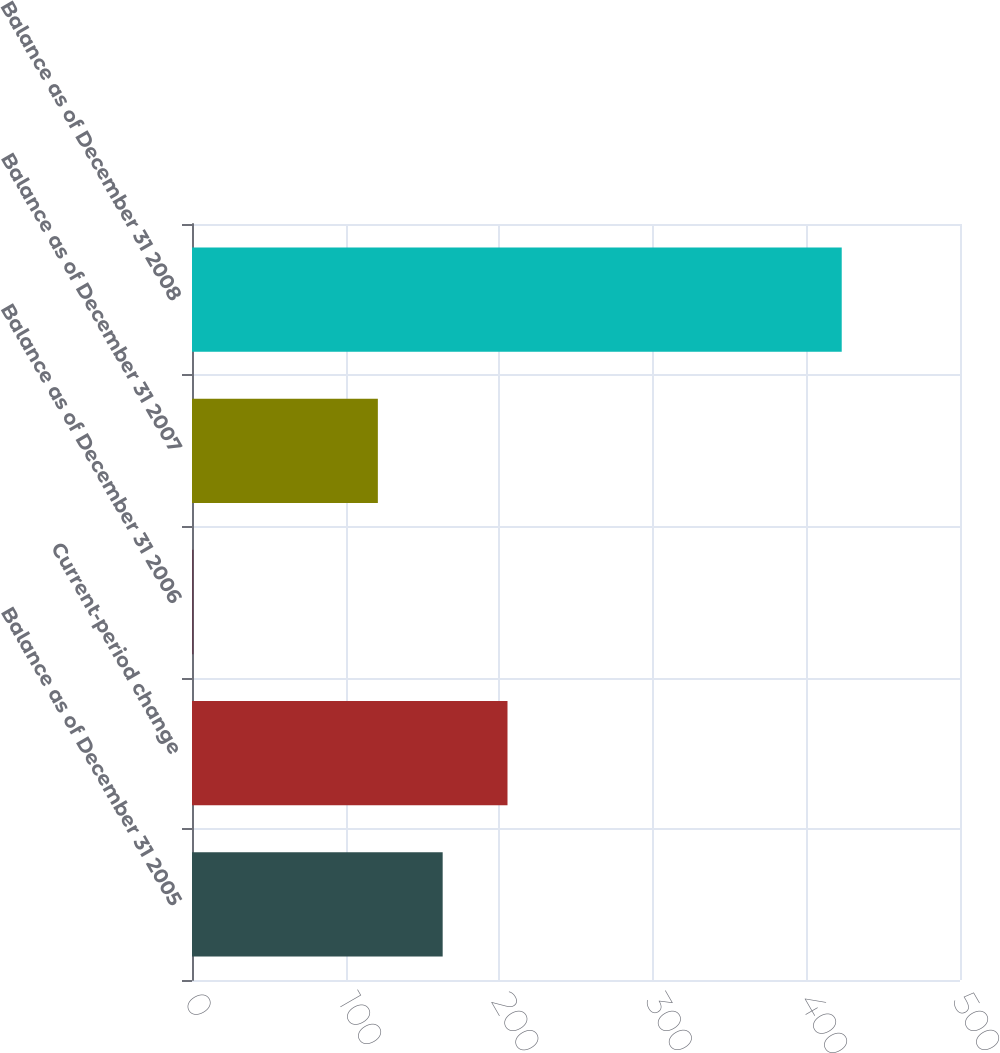Convert chart. <chart><loc_0><loc_0><loc_500><loc_500><bar_chart><fcel>Balance as of December 31 2005<fcel>Current-period change<fcel>Balance as of December 31 2006<fcel>Balance as of December 31 2007<fcel>Balance as of December 31 2008<nl><fcel>163.2<fcel>205.4<fcel>1<fcel>121<fcel>423<nl></chart> 